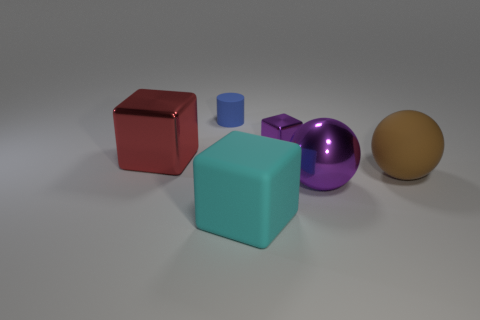Add 1 tiny rubber spheres. How many objects exist? 7 Subtract all cylinders. How many objects are left? 5 Add 3 small metal objects. How many small metal objects are left? 4 Add 3 matte balls. How many matte balls exist? 4 Subtract 1 cyan cubes. How many objects are left? 5 Subtract all large blue cylinders. Subtract all tiny purple blocks. How many objects are left? 5 